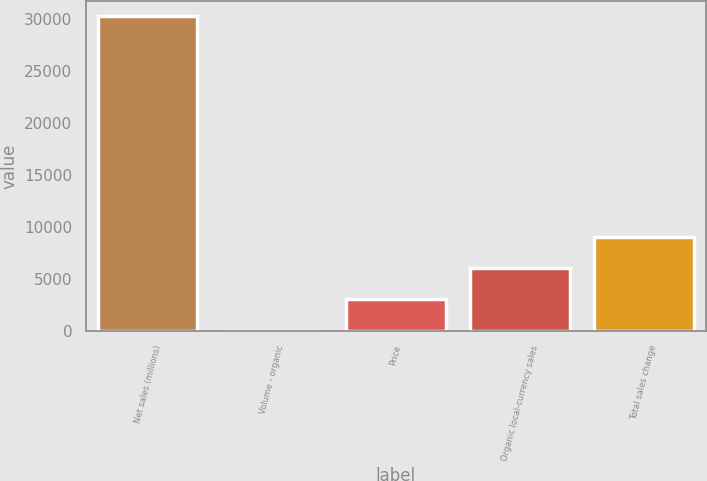Convert chart. <chart><loc_0><loc_0><loc_500><loc_500><bar_chart><fcel>Net sales (millions)<fcel>Volume - organic<fcel>Price<fcel>Organic local-currency sales<fcel>Total sales change<nl><fcel>30274<fcel>0.2<fcel>3027.58<fcel>6054.96<fcel>9082.34<nl></chart> 